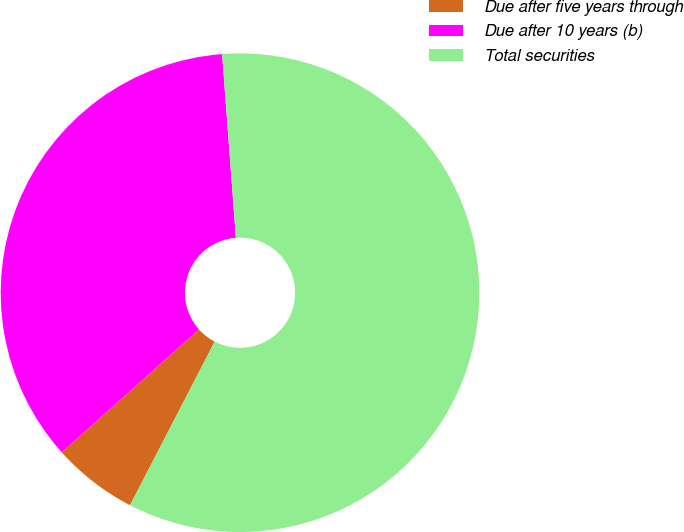Convert chart to OTSL. <chart><loc_0><loc_0><loc_500><loc_500><pie_chart><fcel>Due after five years through<fcel>Due after 10 years (b)<fcel>Total securities<nl><fcel>5.78%<fcel>35.43%<fcel>58.8%<nl></chart> 